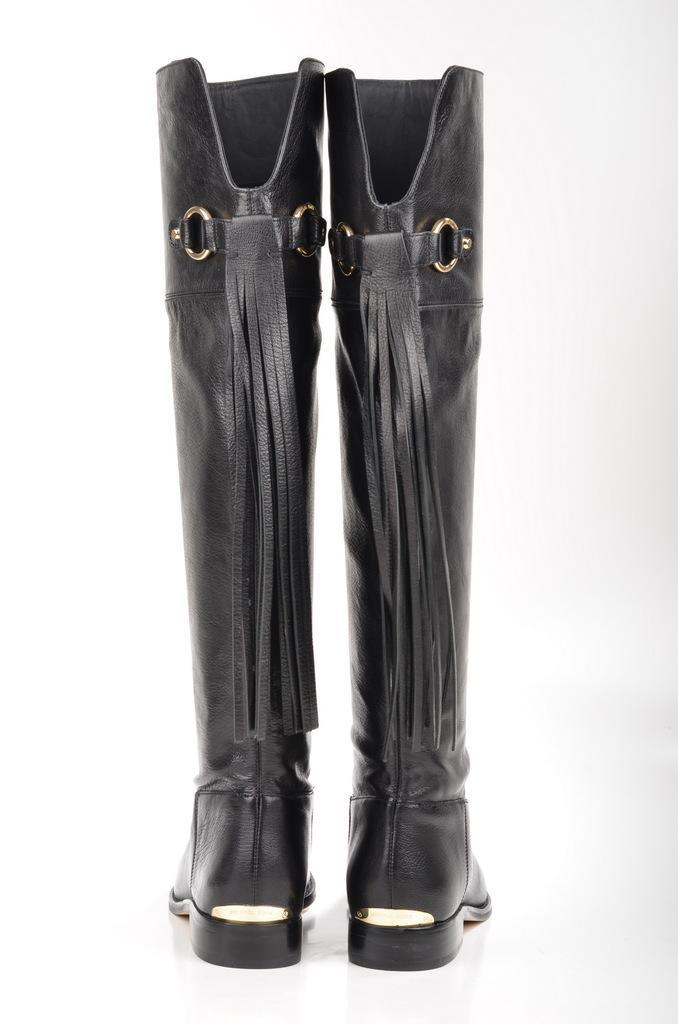Describe this image in one or two sentences. In this image there are boots which are black in colour. 